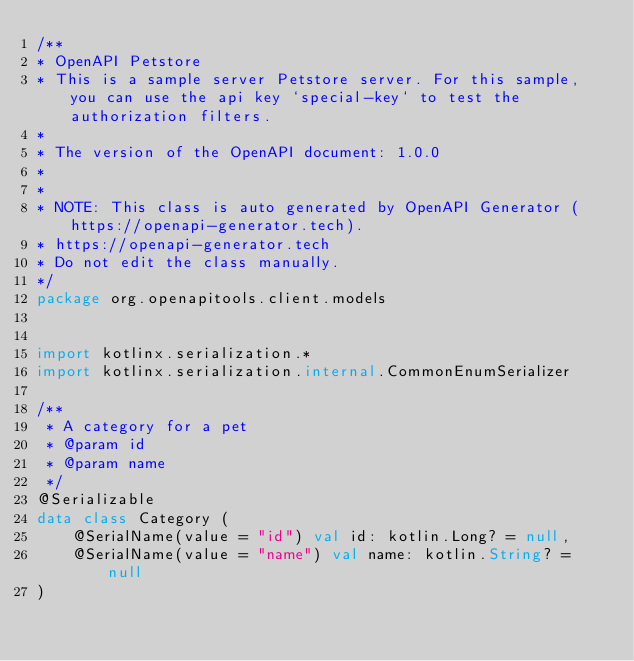<code> <loc_0><loc_0><loc_500><loc_500><_Kotlin_>/**
* OpenAPI Petstore
* This is a sample server Petstore server. For this sample, you can use the api key `special-key` to test the authorization filters.
*
* The version of the OpenAPI document: 1.0.0
* 
*
* NOTE: This class is auto generated by OpenAPI Generator (https://openapi-generator.tech).
* https://openapi-generator.tech
* Do not edit the class manually.
*/
package org.openapitools.client.models


import kotlinx.serialization.*
import kotlinx.serialization.internal.CommonEnumSerializer

/**
 * A category for a pet
 * @param id 
 * @param name 
 */
@Serializable
data class Category (
    @SerialName(value = "id") val id: kotlin.Long? = null,
    @SerialName(value = "name") val name: kotlin.String? = null
)

</code> 